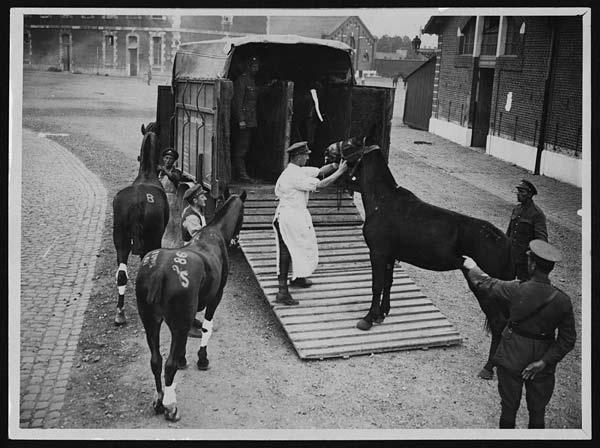How many people are visible in the picture?
Keep it brief. 5. How many animals are there?
Answer briefly. 3. What is the marking on the horse's flank called?
Be succinct. Brand. 